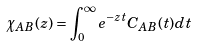Convert formula to latex. <formula><loc_0><loc_0><loc_500><loc_500>\chi _ { A B } ( z ) = \int _ { 0 } ^ { \infty } e ^ { - z t } C _ { A B } ( t ) d t</formula> 